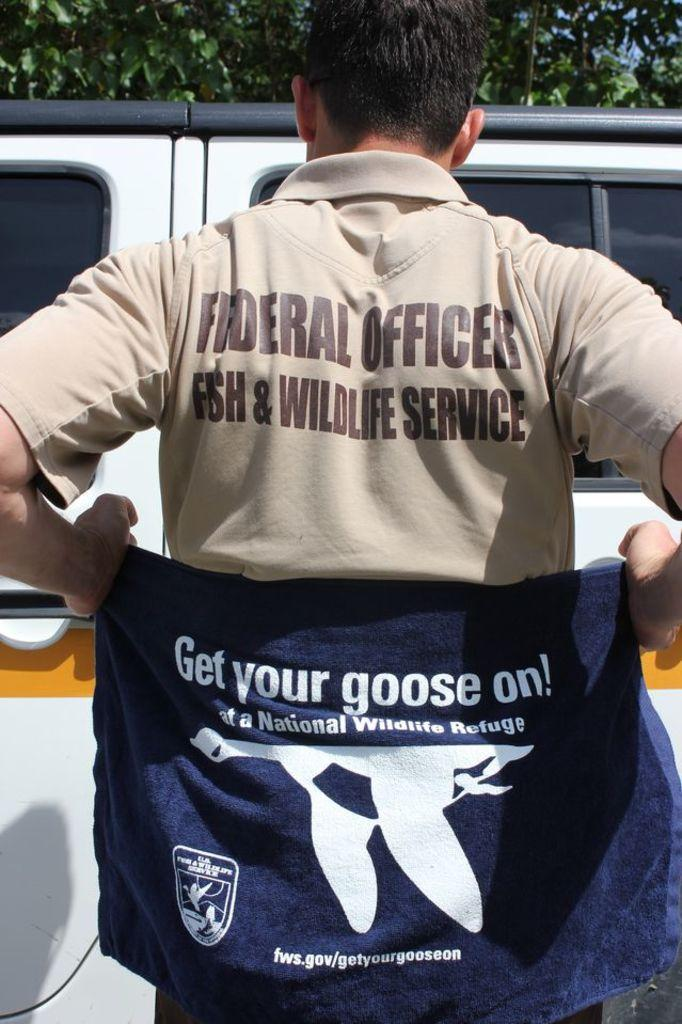Provide a one-sentence caption for the provided image. A man wearing a shirt saying is a federal officer with the fish and wildlife service. 